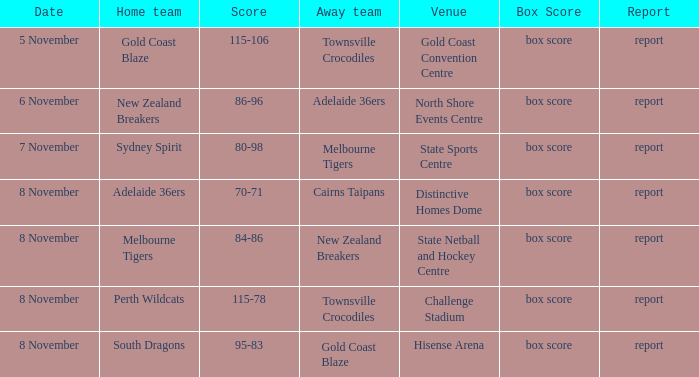On which date was there a game featuring gold coast blaze? 8 November. 